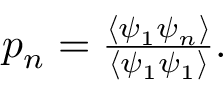<formula> <loc_0><loc_0><loc_500><loc_500>\begin{array} { r } { p _ { n } = \frac { \left < \psi _ { 1 } \psi _ { n } \right > } { \left < \psi _ { 1 } \psi _ { 1 } \right > } . } \end{array}</formula> 